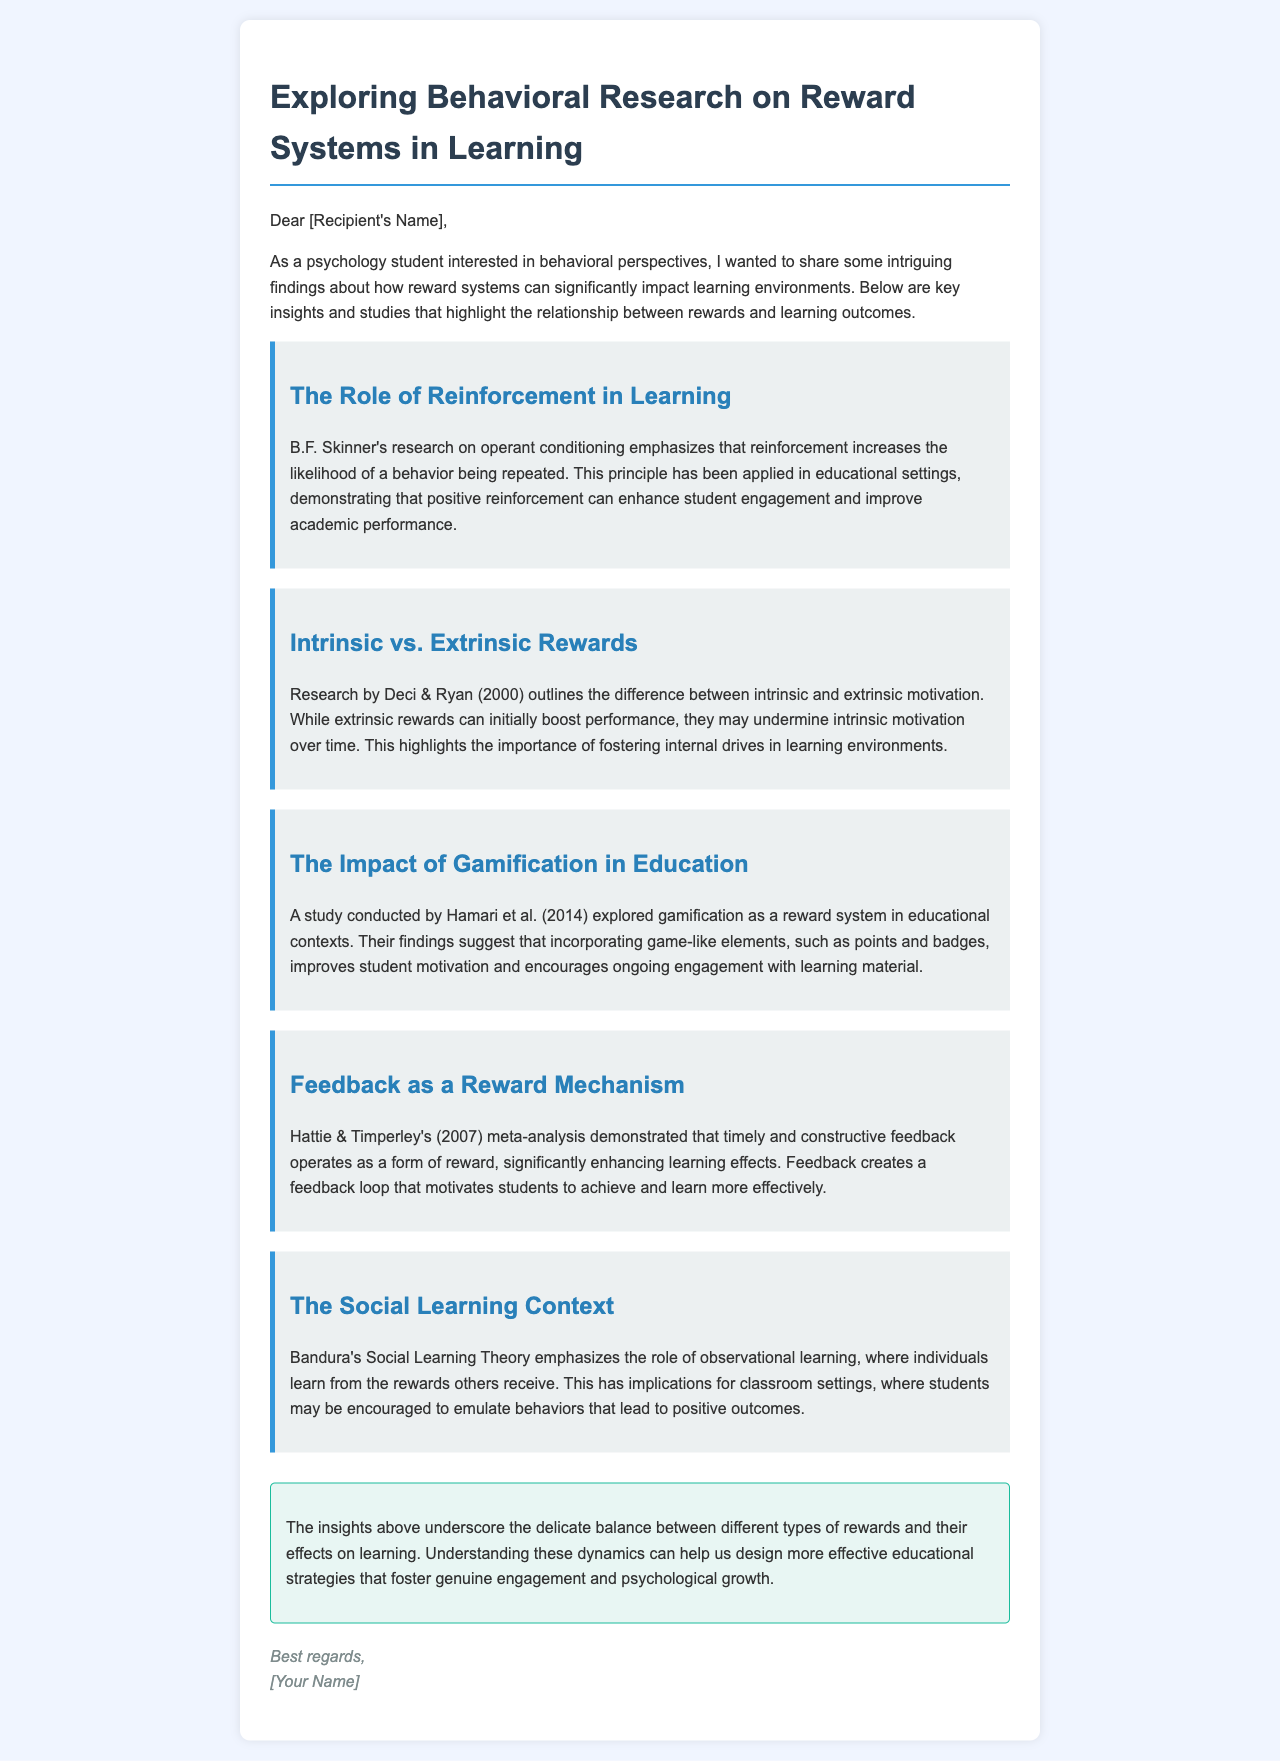What is the first finding mentioned in the email? The first finding is about the role of reinforcement in learning, based on B.F. Skinner's research.
Answer: The Role of Reinforcement in Learning Who conducted the research on intrinsic and extrinsic motivation? The research distinguishing intrinsic from extrinsic motivation was conducted by Deci & Ryan.
Answer: Deci & Ryan What type of educational strategy is highlighted in Hamari et al.'s study? The study focuses on gamification as a reward system in educational contexts.
Answer: Gamification What year was the meta-analysis by Hattie & Timperley published? The meta-analysis conducted by Hattie & Timperley was published in 2007.
Answer: 2007 What psychological theory emphasizes observational learning? The theory that emphasizes observational learning is Bandura's Social Learning Theory.
Answer: Bandura's Social Learning Theory What is a key consequence of extrinsic rewards over time, according to the document? According to the document, extrinsic rewards may undermine intrinsic motivation over time.
Answer: Undermine intrinsic motivation Which element can significantly enhance learning effects according to Hattie & Timperley? Timely and constructive feedback can significantly enhance learning effects.
Answer: Feedback What do the findings in the email imply about feedback? The findings imply that feedback operates as a reward mechanism that motivates students.
Answer: Reward mechanism What is the overall conclusion regarding the balance of rewards in learning? The conclusion states that understanding the dynamics of rewards can help design effective educational strategies.
Answer: Effective educational strategies 